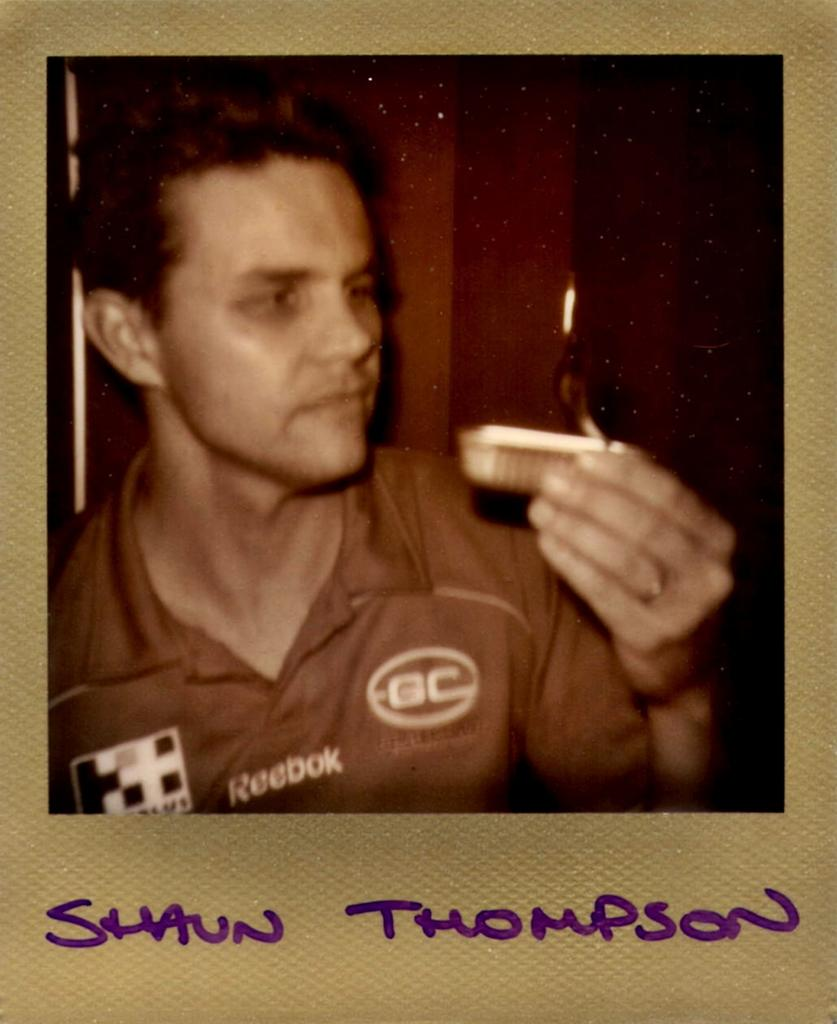What is the main subject of the image? There is a poster in the image. What is depicted on the poster? The poster features a person holding an object. What can be seen behind the poster? There is a background visible in the image. What additional information is provided at the bottom of the poster? There is some text at the bottom of the image. Can you see any fog in the image? There is no fog present in the image; it features a poster with a person holding an object. 